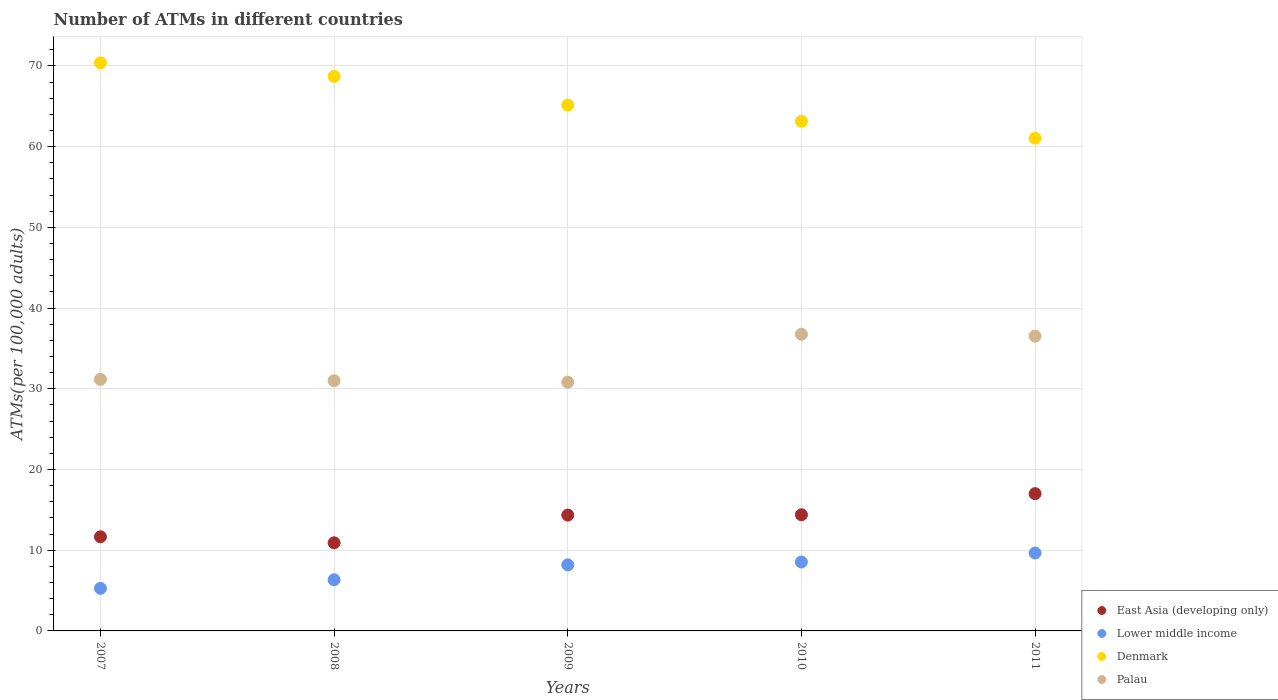Is the number of dotlines equal to the number of legend labels?
Provide a succinct answer. Yes. What is the number of ATMs in Palau in 2008?
Keep it short and to the point. 31. Across all years, what is the maximum number of ATMs in Lower middle income?
Your answer should be compact. 9.65. Across all years, what is the minimum number of ATMs in Lower middle income?
Provide a succinct answer. 5.28. In which year was the number of ATMs in Lower middle income maximum?
Provide a succinct answer. 2011. In which year was the number of ATMs in Palau minimum?
Your answer should be compact. 2009. What is the total number of ATMs in Palau in the graph?
Keep it short and to the point. 166.26. What is the difference between the number of ATMs in Denmark in 2007 and that in 2011?
Offer a terse response. 9.34. What is the difference between the number of ATMs in East Asia (developing only) in 2010 and the number of ATMs in Lower middle income in 2008?
Offer a terse response. 8.05. What is the average number of ATMs in Lower middle income per year?
Your response must be concise. 7.6. In the year 2010, what is the difference between the number of ATMs in East Asia (developing only) and number of ATMs in Denmark?
Ensure brevity in your answer.  -48.76. In how many years, is the number of ATMs in Palau greater than 52?
Ensure brevity in your answer.  0. What is the ratio of the number of ATMs in Lower middle income in 2008 to that in 2010?
Make the answer very short. 0.74. Is the number of ATMs in Denmark in 2007 less than that in 2011?
Offer a very short reply. No. What is the difference between the highest and the second highest number of ATMs in Palau?
Ensure brevity in your answer.  0.24. What is the difference between the highest and the lowest number of ATMs in East Asia (developing only)?
Your answer should be compact. 6.09. In how many years, is the number of ATMs in East Asia (developing only) greater than the average number of ATMs in East Asia (developing only) taken over all years?
Ensure brevity in your answer.  3. Is the sum of the number of ATMs in Lower middle income in 2007 and 2009 greater than the maximum number of ATMs in Denmark across all years?
Your answer should be compact. No. Is it the case that in every year, the sum of the number of ATMs in Lower middle income and number of ATMs in Denmark  is greater than the number of ATMs in East Asia (developing only)?
Your response must be concise. Yes. Is the number of ATMs in East Asia (developing only) strictly less than the number of ATMs in Lower middle income over the years?
Your answer should be very brief. No. How many dotlines are there?
Your response must be concise. 4. How many years are there in the graph?
Make the answer very short. 5. Are the values on the major ticks of Y-axis written in scientific E-notation?
Make the answer very short. No. Does the graph contain any zero values?
Your answer should be very brief. No. Where does the legend appear in the graph?
Your answer should be very brief. Bottom right. How are the legend labels stacked?
Provide a succinct answer. Vertical. What is the title of the graph?
Give a very brief answer. Number of ATMs in different countries. What is the label or title of the Y-axis?
Offer a terse response. ATMs(per 100,0 adults). What is the ATMs(per 100,000 adults) in East Asia (developing only) in 2007?
Provide a short and direct response. 11.66. What is the ATMs(per 100,000 adults) of Lower middle income in 2007?
Your answer should be very brief. 5.28. What is the ATMs(per 100,000 adults) of Denmark in 2007?
Provide a short and direct response. 70.38. What is the ATMs(per 100,000 adults) of Palau in 2007?
Your answer should be very brief. 31.17. What is the ATMs(per 100,000 adults) of East Asia (developing only) in 2008?
Offer a very short reply. 10.92. What is the ATMs(per 100,000 adults) in Lower middle income in 2008?
Offer a terse response. 6.34. What is the ATMs(per 100,000 adults) of Denmark in 2008?
Offer a very short reply. 68.71. What is the ATMs(per 100,000 adults) of Palau in 2008?
Offer a terse response. 31. What is the ATMs(per 100,000 adults) of East Asia (developing only) in 2009?
Provide a short and direct response. 14.35. What is the ATMs(per 100,000 adults) in Lower middle income in 2009?
Keep it short and to the point. 8.19. What is the ATMs(per 100,000 adults) in Denmark in 2009?
Your response must be concise. 65.16. What is the ATMs(per 100,000 adults) of Palau in 2009?
Your answer should be compact. 30.82. What is the ATMs(per 100,000 adults) in East Asia (developing only) in 2010?
Your response must be concise. 14.39. What is the ATMs(per 100,000 adults) of Lower middle income in 2010?
Your response must be concise. 8.54. What is the ATMs(per 100,000 adults) of Denmark in 2010?
Offer a terse response. 63.15. What is the ATMs(per 100,000 adults) of Palau in 2010?
Ensure brevity in your answer.  36.76. What is the ATMs(per 100,000 adults) of East Asia (developing only) in 2011?
Ensure brevity in your answer.  17.01. What is the ATMs(per 100,000 adults) of Lower middle income in 2011?
Provide a short and direct response. 9.65. What is the ATMs(per 100,000 adults) of Denmark in 2011?
Provide a succinct answer. 61.04. What is the ATMs(per 100,000 adults) in Palau in 2011?
Provide a succinct answer. 36.52. Across all years, what is the maximum ATMs(per 100,000 adults) in East Asia (developing only)?
Offer a terse response. 17.01. Across all years, what is the maximum ATMs(per 100,000 adults) of Lower middle income?
Ensure brevity in your answer.  9.65. Across all years, what is the maximum ATMs(per 100,000 adults) of Denmark?
Give a very brief answer. 70.38. Across all years, what is the maximum ATMs(per 100,000 adults) in Palau?
Give a very brief answer. 36.76. Across all years, what is the minimum ATMs(per 100,000 adults) in East Asia (developing only)?
Make the answer very short. 10.92. Across all years, what is the minimum ATMs(per 100,000 adults) in Lower middle income?
Make the answer very short. 5.28. Across all years, what is the minimum ATMs(per 100,000 adults) of Denmark?
Provide a succinct answer. 61.04. Across all years, what is the minimum ATMs(per 100,000 adults) in Palau?
Your answer should be very brief. 30.82. What is the total ATMs(per 100,000 adults) of East Asia (developing only) in the graph?
Give a very brief answer. 68.33. What is the total ATMs(per 100,000 adults) of Lower middle income in the graph?
Offer a very short reply. 38. What is the total ATMs(per 100,000 adults) of Denmark in the graph?
Keep it short and to the point. 328.43. What is the total ATMs(per 100,000 adults) of Palau in the graph?
Offer a very short reply. 166.26. What is the difference between the ATMs(per 100,000 adults) in East Asia (developing only) in 2007 and that in 2008?
Make the answer very short. 0.75. What is the difference between the ATMs(per 100,000 adults) of Lower middle income in 2007 and that in 2008?
Give a very brief answer. -1.06. What is the difference between the ATMs(per 100,000 adults) of Denmark in 2007 and that in 2008?
Keep it short and to the point. 1.68. What is the difference between the ATMs(per 100,000 adults) of Palau in 2007 and that in 2008?
Ensure brevity in your answer.  0.17. What is the difference between the ATMs(per 100,000 adults) in East Asia (developing only) in 2007 and that in 2009?
Your response must be concise. -2.69. What is the difference between the ATMs(per 100,000 adults) of Lower middle income in 2007 and that in 2009?
Your answer should be very brief. -2.91. What is the difference between the ATMs(per 100,000 adults) of Denmark in 2007 and that in 2009?
Provide a succinct answer. 5.23. What is the difference between the ATMs(per 100,000 adults) in Palau in 2007 and that in 2009?
Offer a very short reply. 0.35. What is the difference between the ATMs(per 100,000 adults) in East Asia (developing only) in 2007 and that in 2010?
Make the answer very short. -2.73. What is the difference between the ATMs(per 100,000 adults) of Lower middle income in 2007 and that in 2010?
Your answer should be very brief. -3.26. What is the difference between the ATMs(per 100,000 adults) in Denmark in 2007 and that in 2010?
Make the answer very short. 7.23. What is the difference between the ATMs(per 100,000 adults) in Palau in 2007 and that in 2010?
Make the answer very short. -5.59. What is the difference between the ATMs(per 100,000 adults) in East Asia (developing only) in 2007 and that in 2011?
Provide a short and direct response. -5.35. What is the difference between the ATMs(per 100,000 adults) of Lower middle income in 2007 and that in 2011?
Make the answer very short. -4.37. What is the difference between the ATMs(per 100,000 adults) in Denmark in 2007 and that in 2011?
Provide a short and direct response. 9.34. What is the difference between the ATMs(per 100,000 adults) in Palau in 2007 and that in 2011?
Give a very brief answer. -5.35. What is the difference between the ATMs(per 100,000 adults) in East Asia (developing only) in 2008 and that in 2009?
Provide a succinct answer. -3.44. What is the difference between the ATMs(per 100,000 adults) in Lower middle income in 2008 and that in 2009?
Give a very brief answer. -1.85. What is the difference between the ATMs(per 100,000 adults) of Denmark in 2008 and that in 2009?
Make the answer very short. 3.55. What is the difference between the ATMs(per 100,000 adults) of Palau in 2008 and that in 2009?
Offer a terse response. 0.18. What is the difference between the ATMs(per 100,000 adults) of East Asia (developing only) in 2008 and that in 2010?
Provide a short and direct response. -3.48. What is the difference between the ATMs(per 100,000 adults) in Lower middle income in 2008 and that in 2010?
Keep it short and to the point. -2.2. What is the difference between the ATMs(per 100,000 adults) of Denmark in 2008 and that in 2010?
Ensure brevity in your answer.  5.56. What is the difference between the ATMs(per 100,000 adults) in Palau in 2008 and that in 2010?
Your response must be concise. -5.76. What is the difference between the ATMs(per 100,000 adults) of East Asia (developing only) in 2008 and that in 2011?
Offer a very short reply. -6.09. What is the difference between the ATMs(per 100,000 adults) of Lower middle income in 2008 and that in 2011?
Provide a short and direct response. -3.31. What is the difference between the ATMs(per 100,000 adults) in Denmark in 2008 and that in 2011?
Your answer should be compact. 7.66. What is the difference between the ATMs(per 100,000 adults) of Palau in 2008 and that in 2011?
Make the answer very short. -5.52. What is the difference between the ATMs(per 100,000 adults) in East Asia (developing only) in 2009 and that in 2010?
Your answer should be very brief. -0.04. What is the difference between the ATMs(per 100,000 adults) in Lower middle income in 2009 and that in 2010?
Your answer should be very brief. -0.35. What is the difference between the ATMs(per 100,000 adults) in Denmark in 2009 and that in 2010?
Your answer should be compact. 2.01. What is the difference between the ATMs(per 100,000 adults) in Palau in 2009 and that in 2010?
Make the answer very short. -5.94. What is the difference between the ATMs(per 100,000 adults) in East Asia (developing only) in 2009 and that in 2011?
Provide a succinct answer. -2.66. What is the difference between the ATMs(per 100,000 adults) of Lower middle income in 2009 and that in 2011?
Provide a short and direct response. -1.46. What is the difference between the ATMs(per 100,000 adults) of Denmark in 2009 and that in 2011?
Ensure brevity in your answer.  4.11. What is the difference between the ATMs(per 100,000 adults) in Palau in 2009 and that in 2011?
Ensure brevity in your answer.  -5.69. What is the difference between the ATMs(per 100,000 adults) in East Asia (developing only) in 2010 and that in 2011?
Offer a terse response. -2.62. What is the difference between the ATMs(per 100,000 adults) of Lower middle income in 2010 and that in 2011?
Give a very brief answer. -1.11. What is the difference between the ATMs(per 100,000 adults) of Denmark in 2010 and that in 2011?
Offer a terse response. 2.11. What is the difference between the ATMs(per 100,000 adults) of Palau in 2010 and that in 2011?
Your answer should be compact. 0.24. What is the difference between the ATMs(per 100,000 adults) in East Asia (developing only) in 2007 and the ATMs(per 100,000 adults) in Lower middle income in 2008?
Provide a short and direct response. 5.32. What is the difference between the ATMs(per 100,000 adults) in East Asia (developing only) in 2007 and the ATMs(per 100,000 adults) in Denmark in 2008?
Your response must be concise. -57.04. What is the difference between the ATMs(per 100,000 adults) in East Asia (developing only) in 2007 and the ATMs(per 100,000 adults) in Palau in 2008?
Keep it short and to the point. -19.34. What is the difference between the ATMs(per 100,000 adults) in Lower middle income in 2007 and the ATMs(per 100,000 adults) in Denmark in 2008?
Offer a terse response. -63.43. What is the difference between the ATMs(per 100,000 adults) of Lower middle income in 2007 and the ATMs(per 100,000 adults) of Palau in 2008?
Your answer should be very brief. -25.72. What is the difference between the ATMs(per 100,000 adults) in Denmark in 2007 and the ATMs(per 100,000 adults) in Palau in 2008?
Ensure brevity in your answer.  39.38. What is the difference between the ATMs(per 100,000 adults) in East Asia (developing only) in 2007 and the ATMs(per 100,000 adults) in Lower middle income in 2009?
Give a very brief answer. 3.47. What is the difference between the ATMs(per 100,000 adults) in East Asia (developing only) in 2007 and the ATMs(per 100,000 adults) in Denmark in 2009?
Make the answer very short. -53.49. What is the difference between the ATMs(per 100,000 adults) of East Asia (developing only) in 2007 and the ATMs(per 100,000 adults) of Palau in 2009?
Ensure brevity in your answer.  -19.16. What is the difference between the ATMs(per 100,000 adults) of Lower middle income in 2007 and the ATMs(per 100,000 adults) of Denmark in 2009?
Keep it short and to the point. -59.88. What is the difference between the ATMs(per 100,000 adults) in Lower middle income in 2007 and the ATMs(per 100,000 adults) in Palau in 2009?
Your response must be concise. -25.54. What is the difference between the ATMs(per 100,000 adults) in Denmark in 2007 and the ATMs(per 100,000 adults) in Palau in 2009?
Provide a succinct answer. 39.56. What is the difference between the ATMs(per 100,000 adults) of East Asia (developing only) in 2007 and the ATMs(per 100,000 adults) of Lower middle income in 2010?
Ensure brevity in your answer.  3.12. What is the difference between the ATMs(per 100,000 adults) in East Asia (developing only) in 2007 and the ATMs(per 100,000 adults) in Denmark in 2010?
Provide a short and direct response. -51.49. What is the difference between the ATMs(per 100,000 adults) in East Asia (developing only) in 2007 and the ATMs(per 100,000 adults) in Palau in 2010?
Give a very brief answer. -25.1. What is the difference between the ATMs(per 100,000 adults) of Lower middle income in 2007 and the ATMs(per 100,000 adults) of Denmark in 2010?
Your response must be concise. -57.87. What is the difference between the ATMs(per 100,000 adults) in Lower middle income in 2007 and the ATMs(per 100,000 adults) in Palau in 2010?
Offer a terse response. -31.48. What is the difference between the ATMs(per 100,000 adults) in Denmark in 2007 and the ATMs(per 100,000 adults) in Palau in 2010?
Make the answer very short. 33.62. What is the difference between the ATMs(per 100,000 adults) of East Asia (developing only) in 2007 and the ATMs(per 100,000 adults) of Lower middle income in 2011?
Give a very brief answer. 2.01. What is the difference between the ATMs(per 100,000 adults) of East Asia (developing only) in 2007 and the ATMs(per 100,000 adults) of Denmark in 2011?
Provide a short and direct response. -49.38. What is the difference between the ATMs(per 100,000 adults) in East Asia (developing only) in 2007 and the ATMs(per 100,000 adults) in Palau in 2011?
Provide a short and direct response. -24.85. What is the difference between the ATMs(per 100,000 adults) of Lower middle income in 2007 and the ATMs(per 100,000 adults) of Denmark in 2011?
Your answer should be compact. -55.76. What is the difference between the ATMs(per 100,000 adults) in Lower middle income in 2007 and the ATMs(per 100,000 adults) in Palau in 2011?
Give a very brief answer. -31.24. What is the difference between the ATMs(per 100,000 adults) of Denmark in 2007 and the ATMs(per 100,000 adults) of Palau in 2011?
Your answer should be compact. 33.87. What is the difference between the ATMs(per 100,000 adults) in East Asia (developing only) in 2008 and the ATMs(per 100,000 adults) in Lower middle income in 2009?
Provide a short and direct response. 2.73. What is the difference between the ATMs(per 100,000 adults) in East Asia (developing only) in 2008 and the ATMs(per 100,000 adults) in Denmark in 2009?
Make the answer very short. -54.24. What is the difference between the ATMs(per 100,000 adults) in East Asia (developing only) in 2008 and the ATMs(per 100,000 adults) in Palau in 2009?
Provide a succinct answer. -19.91. What is the difference between the ATMs(per 100,000 adults) of Lower middle income in 2008 and the ATMs(per 100,000 adults) of Denmark in 2009?
Your answer should be very brief. -58.81. What is the difference between the ATMs(per 100,000 adults) in Lower middle income in 2008 and the ATMs(per 100,000 adults) in Palau in 2009?
Give a very brief answer. -24.48. What is the difference between the ATMs(per 100,000 adults) in Denmark in 2008 and the ATMs(per 100,000 adults) in Palau in 2009?
Offer a terse response. 37.88. What is the difference between the ATMs(per 100,000 adults) of East Asia (developing only) in 2008 and the ATMs(per 100,000 adults) of Lower middle income in 2010?
Your answer should be very brief. 2.38. What is the difference between the ATMs(per 100,000 adults) in East Asia (developing only) in 2008 and the ATMs(per 100,000 adults) in Denmark in 2010?
Provide a succinct answer. -52.23. What is the difference between the ATMs(per 100,000 adults) in East Asia (developing only) in 2008 and the ATMs(per 100,000 adults) in Palau in 2010?
Offer a very short reply. -25.84. What is the difference between the ATMs(per 100,000 adults) of Lower middle income in 2008 and the ATMs(per 100,000 adults) of Denmark in 2010?
Make the answer very short. -56.81. What is the difference between the ATMs(per 100,000 adults) of Lower middle income in 2008 and the ATMs(per 100,000 adults) of Palau in 2010?
Your answer should be compact. -30.42. What is the difference between the ATMs(per 100,000 adults) of Denmark in 2008 and the ATMs(per 100,000 adults) of Palau in 2010?
Your response must be concise. 31.95. What is the difference between the ATMs(per 100,000 adults) of East Asia (developing only) in 2008 and the ATMs(per 100,000 adults) of Lower middle income in 2011?
Offer a terse response. 1.26. What is the difference between the ATMs(per 100,000 adults) of East Asia (developing only) in 2008 and the ATMs(per 100,000 adults) of Denmark in 2011?
Your answer should be very brief. -50.13. What is the difference between the ATMs(per 100,000 adults) in East Asia (developing only) in 2008 and the ATMs(per 100,000 adults) in Palau in 2011?
Make the answer very short. -25.6. What is the difference between the ATMs(per 100,000 adults) of Lower middle income in 2008 and the ATMs(per 100,000 adults) of Denmark in 2011?
Offer a very short reply. -54.7. What is the difference between the ATMs(per 100,000 adults) in Lower middle income in 2008 and the ATMs(per 100,000 adults) in Palau in 2011?
Your response must be concise. -30.17. What is the difference between the ATMs(per 100,000 adults) of Denmark in 2008 and the ATMs(per 100,000 adults) of Palau in 2011?
Your answer should be compact. 32.19. What is the difference between the ATMs(per 100,000 adults) in East Asia (developing only) in 2009 and the ATMs(per 100,000 adults) in Lower middle income in 2010?
Provide a succinct answer. 5.81. What is the difference between the ATMs(per 100,000 adults) of East Asia (developing only) in 2009 and the ATMs(per 100,000 adults) of Denmark in 2010?
Provide a short and direct response. -48.8. What is the difference between the ATMs(per 100,000 adults) of East Asia (developing only) in 2009 and the ATMs(per 100,000 adults) of Palau in 2010?
Give a very brief answer. -22.41. What is the difference between the ATMs(per 100,000 adults) in Lower middle income in 2009 and the ATMs(per 100,000 adults) in Denmark in 2010?
Provide a succinct answer. -54.96. What is the difference between the ATMs(per 100,000 adults) of Lower middle income in 2009 and the ATMs(per 100,000 adults) of Palau in 2010?
Keep it short and to the point. -28.57. What is the difference between the ATMs(per 100,000 adults) in Denmark in 2009 and the ATMs(per 100,000 adults) in Palau in 2010?
Provide a succinct answer. 28.4. What is the difference between the ATMs(per 100,000 adults) of East Asia (developing only) in 2009 and the ATMs(per 100,000 adults) of Denmark in 2011?
Provide a short and direct response. -46.69. What is the difference between the ATMs(per 100,000 adults) of East Asia (developing only) in 2009 and the ATMs(per 100,000 adults) of Palau in 2011?
Provide a succinct answer. -22.16. What is the difference between the ATMs(per 100,000 adults) of Lower middle income in 2009 and the ATMs(per 100,000 adults) of Denmark in 2011?
Give a very brief answer. -52.85. What is the difference between the ATMs(per 100,000 adults) of Lower middle income in 2009 and the ATMs(per 100,000 adults) of Palau in 2011?
Your answer should be compact. -28.33. What is the difference between the ATMs(per 100,000 adults) of Denmark in 2009 and the ATMs(per 100,000 adults) of Palau in 2011?
Offer a terse response. 28.64. What is the difference between the ATMs(per 100,000 adults) in East Asia (developing only) in 2010 and the ATMs(per 100,000 adults) in Lower middle income in 2011?
Offer a terse response. 4.74. What is the difference between the ATMs(per 100,000 adults) in East Asia (developing only) in 2010 and the ATMs(per 100,000 adults) in Denmark in 2011?
Ensure brevity in your answer.  -46.65. What is the difference between the ATMs(per 100,000 adults) of East Asia (developing only) in 2010 and the ATMs(per 100,000 adults) of Palau in 2011?
Provide a succinct answer. -22.12. What is the difference between the ATMs(per 100,000 adults) in Lower middle income in 2010 and the ATMs(per 100,000 adults) in Denmark in 2011?
Provide a short and direct response. -52.5. What is the difference between the ATMs(per 100,000 adults) in Lower middle income in 2010 and the ATMs(per 100,000 adults) in Palau in 2011?
Give a very brief answer. -27.98. What is the difference between the ATMs(per 100,000 adults) of Denmark in 2010 and the ATMs(per 100,000 adults) of Palau in 2011?
Make the answer very short. 26.63. What is the average ATMs(per 100,000 adults) of East Asia (developing only) per year?
Ensure brevity in your answer.  13.67. What is the average ATMs(per 100,000 adults) in Lower middle income per year?
Give a very brief answer. 7.6. What is the average ATMs(per 100,000 adults) in Denmark per year?
Your answer should be compact. 65.69. What is the average ATMs(per 100,000 adults) in Palau per year?
Your answer should be very brief. 33.25. In the year 2007, what is the difference between the ATMs(per 100,000 adults) in East Asia (developing only) and ATMs(per 100,000 adults) in Lower middle income?
Give a very brief answer. 6.38. In the year 2007, what is the difference between the ATMs(per 100,000 adults) in East Asia (developing only) and ATMs(per 100,000 adults) in Denmark?
Your response must be concise. -58.72. In the year 2007, what is the difference between the ATMs(per 100,000 adults) of East Asia (developing only) and ATMs(per 100,000 adults) of Palau?
Your answer should be very brief. -19.51. In the year 2007, what is the difference between the ATMs(per 100,000 adults) of Lower middle income and ATMs(per 100,000 adults) of Denmark?
Your response must be concise. -65.1. In the year 2007, what is the difference between the ATMs(per 100,000 adults) of Lower middle income and ATMs(per 100,000 adults) of Palau?
Your answer should be very brief. -25.89. In the year 2007, what is the difference between the ATMs(per 100,000 adults) of Denmark and ATMs(per 100,000 adults) of Palau?
Your answer should be compact. 39.21. In the year 2008, what is the difference between the ATMs(per 100,000 adults) of East Asia (developing only) and ATMs(per 100,000 adults) of Lower middle income?
Provide a short and direct response. 4.57. In the year 2008, what is the difference between the ATMs(per 100,000 adults) of East Asia (developing only) and ATMs(per 100,000 adults) of Denmark?
Ensure brevity in your answer.  -57.79. In the year 2008, what is the difference between the ATMs(per 100,000 adults) of East Asia (developing only) and ATMs(per 100,000 adults) of Palau?
Ensure brevity in your answer.  -20.08. In the year 2008, what is the difference between the ATMs(per 100,000 adults) in Lower middle income and ATMs(per 100,000 adults) in Denmark?
Offer a very short reply. -62.36. In the year 2008, what is the difference between the ATMs(per 100,000 adults) in Lower middle income and ATMs(per 100,000 adults) in Palau?
Provide a short and direct response. -24.66. In the year 2008, what is the difference between the ATMs(per 100,000 adults) in Denmark and ATMs(per 100,000 adults) in Palau?
Ensure brevity in your answer.  37.71. In the year 2009, what is the difference between the ATMs(per 100,000 adults) of East Asia (developing only) and ATMs(per 100,000 adults) of Lower middle income?
Offer a very short reply. 6.16. In the year 2009, what is the difference between the ATMs(per 100,000 adults) in East Asia (developing only) and ATMs(per 100,000 adults) in Denmark?
Give a very brief answer. -50.8. In the year 2009, what is the difference between the ATMs(per 100,000 adults) in East Asia (developing only) and ATMs(per 100,000 adults) in Palau?
Provide a succinct answer. -16.47. In the year 2009, what is the difference between the ATMs(per 100,000 adults) in Lower middle income and ATMs(per 100,000 adults) in Denmark?
Make the answer very short. -56.97. In the year 2009, what is the difference between the ATMs(per 100,000 adults) in Lower middle income and ATMs(per 100,000 adults) in Palau?
Provide a succinct answer. -22.63. In the year 2009, what is the difference between the ATMs(per 100,000 adults) in Denmark and ATMs(per 100,000 adults) in Palau?
Keep it short and to the point. 34.33. In the year 2010, what is the difference between the ATMs(per 100,000 adults) in East Asia (developing only) and ATMs(per 100,000 adults) in Lower middle income?
Give a very brief answer. 5.85. In the year 2010, what is the difference between the ATMs(per 100,000 adults) in East Asia (developing only) and ATMs(per 100,000 adults) in Denmark?
Provide a succinct answer. -48.76. In the year 2010, what is the difference between the ATMs(per 100,000 adults) in East Asia (developing only) and ATMs(per 100,000 adults) in Palau?
Offer a terse response. -22.37. In the year 2010, what is the difference between the ATMs(per 100,000 adults) of Lower middle income and ATMs(per 100,000 adults) of Denmark?
Offer a terse response. -54.61. In the year 2010, what is the difference between the ATMs(per 100,000 adults) of Lower middle income and ATMs(per 100,000 adults) of Palau?
Give a very brief answer. -28.22. In the year 2010, what is the difference between the ATMs(per 100,000 adults) in Denmark and ATMs(per 100,000 adults) in Palau?
Offer a terse response. 26.39. In the year 2011, what is the difference between the ATMs(per 100,000 adults) of East Asia (developing only) and ATMs(per 100,000 adults) of Lower middle income?
Ensure brevity in your answer.  7.36. In the year 2011, what is the difference between the ATMs(per 100,000 adults) of East Asia (developing only) and ATMs(per 100,000 adults) of Denmark?
Your answer should be compact. -44.03. In the year 2011, what is the difference between the ATMs(per 100,000 adults) of East Asia (developing only) and ATMs(per 100,000 adults) of Palau?
Offer a terse response. -19.51. In the year 2011, what is the difference between the ATMs(per 100,000 adults) in Lower middle income and ATMs(per 100,000 adults) in Denmark?
Ensure brevity in your answer.  -51.39. In the year 2011, what is the difference between the ATMs(per 100,000 adults) in Lower middle income and ATMs(per 100,000 adults) in Palau?
Your answer should be compact. -26.86. In the year 2011, what is the difference between the ATMs(per 100,000 adults) in Denmark and ATMs(per 100,000 adults) in Palau?
Make the answer very short. 24.53. What is the ratio of the ATMs(per 100,000 adults) of East Asia (developing only) in 2007 to that in 2008?
Your answer should be compact. 1.07. What is the ratio of the ATMs(per 100,000 adults) in Lower middle income in 2007 to that in 2008?
Give a very brief answer. 0.83. What is the ratio of the ATMs(per 100,000 adults) in Denmark in 2007 to that in 2008?
Offer a very short reply. 1.02. What is the ratio of the ATMs(per 100,000 adults) in Palau in 2007 to that in 2008?
Provide a short and direct response. 1.01. What is the ratio of the ATMs(per 100,000 adults) in East Asia (developing only) in 2007 to that in 2009?
Your answer should be very brief. 0.81. What is the ratio of the ATMs(per 100,000 adults) of Lower middle income in 2007 to that in 2009?
Keep it short and to the point. 0.64. What is the ratio of the ATMs(per 100,000 adults) in Denmark in 2007 to that in 2009?
Offer a terse response. 1.08. What is the ratio of the ATMs(per 100,000 adults) of Palau in 2007 to that in 2009?
Keep it short and to the point. 1.01. What is the ratio of the ATMs(per 100,000 adults) of East Asia (developing only) in 2007 to that in 2010?
Your answer should be compact. 0.81. What is the ratio of the ATMs(per 100,000 adults) of Lower middle income in 2007 to that in 2010?
Ensure brevity in your answer.  0.62. What is the ratio of the ATMs(per 100,000 adults) of Denmark in 2007 to that in 2010?
Your response must be concise. 1.11. What is the ratio of the ATMs(per 100,000 adults) in Palau in 2007 to that in 2010?
Your answer should be very brief. 0.85. What is the ratio of the ATMs(per 100,000 adults) of East Asia (developing only) in 2007 to that in 2011?
Make the answer very short. 0.69. What is the ratio of the ATMs(per 100,000 adults) of Lower middle income in 2007 to that in 2011?
Ensure brevity in your answer.  0.55. What is the ratio of the ATMs(per 100,000 adults) of Denmark in 2007 to that in 2011?
Offer a terse response. 1.15. What is the ratio of the ATMs(per 100,000 adults) in Palau in 2007 to that in 2011?
Your response must be concise. 0.85. What is the ratio of the ATMs(per 100,000 adults) of East Asia (developing only) in 2008 to that in 2009?
Make the answer very short. 0.76. What is the ratio of the ATMs(per 100,000 adults) of Lower middle income in 2008 to that in 2009?
Your response must be concise. 0.77. What is the ratio of the ATMs(per 100,000 adults) in Denmark in 2008 to that in 2009?
Make the answer very short. 1.05. What is the ratio of the ATMs(per 100,000 adults) of Palau in 2008 to that in 2009?
Ensure brevity in your answer.  1.01. What is the ratio of the ATMs(per 100,000 adults) in East Asia (developing only) in 2008 to that in 2010?
Give a very brief answer. 0.76. What is the ratio of the ATMs(per 100,000 adults) of Lower middle income in 2008 to that in 2010?
Your answer should be compact. 0.74. What is the ratio of the ATMs(per 100,000 adults) in Denmark in 2008 to that in 2010?
Ensure brevity in your answer.  1.09. What is the ratio of the ATMs(per 100,000 adults) in Palau in 2008 to that in 2010?
Your answer should be very brief. 0.84. What is the ratio of the ATMs(per 100,000 adults) in East Asia (developing only) in 2008 to that in 2011?
Make the answer very short. 0.64. What is the ratio of the ATMs(per 100,000 adults) of Lower middle income in 2008 to that in 2011?
Provide a succinct answer. 0.66. What is the ratio of the ATMs(per 100,000 adults) in Denmark in 2008 to that in 2011?
Keep it short and to the point. 1.13. What is the ratio of the ATMs(per 100,000 adults) of Palau in 2008 to that in 2011?
Give a very brief answer. 0.85. What is the ratio of the ATMs(per 100,000 adults) of Lower middle income in 2009 to that in 2010?
Offer a terse response. 0.96. What is the ratio of the ATMs(per 100,000 adults) in Denmark in 2009 to that in 2010?
Your answer should be compact. 1.03. What is the ratio of the ATMs(per 100,000 adults) in Palau in 2009 to that in 2010?
Provide a succinct answer. 0.84. What is the ratio of the ATMs(per 100,000 adults) of East Asia (developing only) in 2009 to that in 2011?
Offer a terse response. 0.84. What is the ratio of the ATMs(per 100,000 adults) in Lower middle income in 2009 to that in 2011?
Your answer should be compact. 0.85. What is the ratio of the ATMs(per 100,000 adults) of Denmark in 2009 to that in 2011?
Provide a succinct answer. 1.07. What is the ratio of the ATMs(per 100,000 adults) in Palau in 2009 to that in 2011?
Keep it short and to the point. 0.84. What is the ratio of the ATMs(per 100,000 adults) of East Asia (developing only) in 2010 to that in 2011?
Provide a succinct answer. 0.85. What is the ratio of the ATMs(per 100,000 adults) in Lower middle income in 2010 to that in 2011?
Give a very brief answer. 0.88. What is the ratio of the ATMs(per 100,000 adults) of Denmark in 2010 to that in 2011?
Keep it short and to the point. 1.03. What is the ratio of the ATMs(per 100,000 adults) of Palau in 2010 to that in 2011?
Provide a short and direct response. 1.01. What is the difference between the highest and the second highest ATMs(per 100,000 adults) of East Asia (developing only)?
Make the answer very short. 2.62. What is the difference between the highest and the second highest ATMs(per 100,000 adults) of Lower middle income?
Offer a terse response. 1.11. What is the difference between the highest and the second highest ATMs(per 100,000 adults) in Denmark?
Offer a terse response. 1.68. What is the difference between the highest and the second highest ATMs(per 100,000 adults) in Palau?
Your answer should be compact. 0.24. What is the difference between the highest and the lowest ATMs(per 100,000 adults) of East Asia (developing only)?
Keep it short and to the point. 6.09. What is the difference between the highest and the lowest ATMs(per 100,000 adults) of Lower middle income?
Your answer should be very brief. 4.37. What is the difference between the highest and the lowest ATMs(per 100,000 adults) in Denmark?
Your answer should be very brief. 9.34. What is the difference between the highest and the lowest ATMs(per 100,000 adults) of Palau?
Provide a short and direct response. 5.94. 